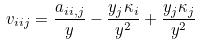Convert formula to latex. <formula><loc_0><loc_0><loc_500><loc_500>v _ { i i j } = \frac { a _ { i i , j } } { y } - \frac { y _ { j } \kappa _ { i } } { y ^ { 2 } } + \frac { y _ { j } \kappa _ { j } } { y ^ { 2 } }</formula> 